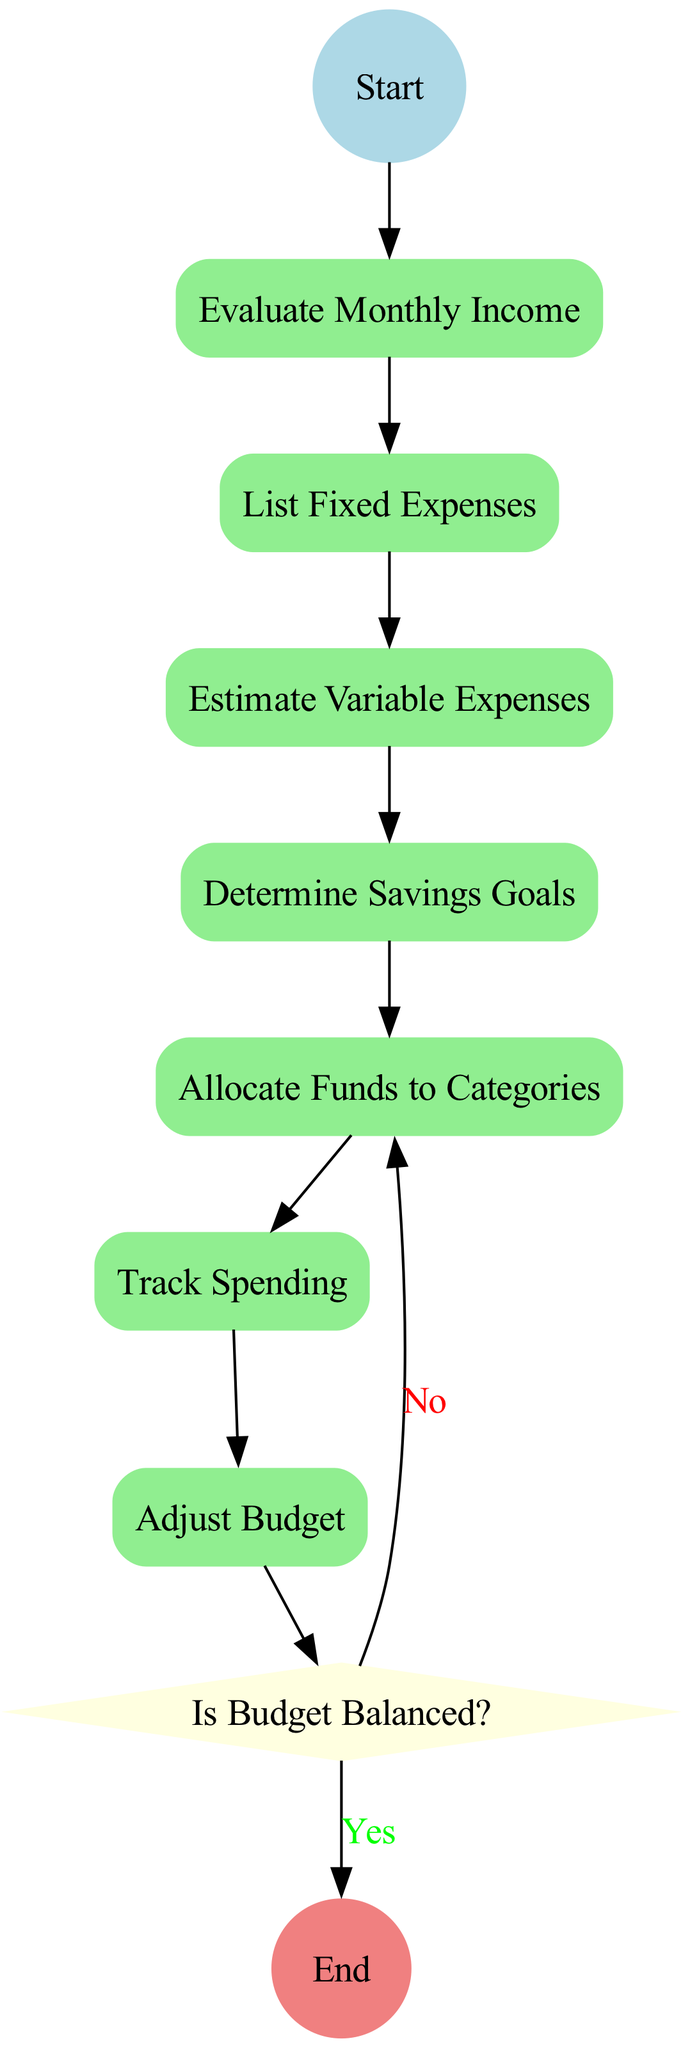What is the first activity in the diagram? The first activity is labeled as "Evaluate Monthly Income", which follows the start state. The flow of the diagram starts at the "Start" node and proceeds to the first activity.
Answer: Evaluate Monthly Income How many activities are listed in the diagram? The diagram contains a total of 7 activities. Each activity is represented as a rectangle and can be counted from the provided data.
Answer: 7 What is the last activity before the decision point? The last activity before the decision point is "Allocate Funds to Categories". It is the final activity in the sequential flow leading to the decision node.
Answer: Allocate Funds to Categories What happens if the budget is balanced? If the budget is balanced, the flow leads directly to the end state according to the decision point. This indicates that no more adjustments are needed for the budget.
Answer: End What is the decision point in the diagram? The decision point is labeled "Is Budget Balanced?". It determines the flow based on whether the budget is not exceeding income.
Answer: Is Budget Balanced? What do you do after estimating variable expenses? After estimating variable expenses, the next step is to determine savings goals. This is the sequential order of activities as per the diagram.
Answer: Determine Savings Goals What action follows after tracking spending? After tracking spending, the action that follows is to adjust the budget if necessary. The flow in the diagram proceeds from tracking spending directly to adjusting the budget.
Answer: Adjust Budget What color is the start state node? The start state node is colored light blue, as indicated in the properties of the node in the diagram.
Answer: Light blue 